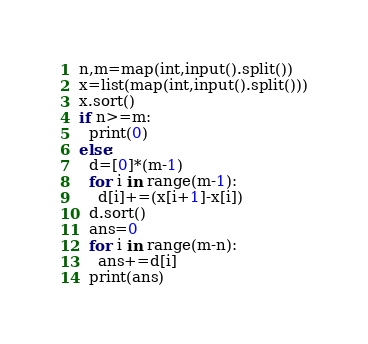Convert code to text. <code><loc_0><loc_0><loc_500><loc_500><_Python_>n,m=map(int,input().split())
x=list(map(int,input().split()))
x.sort()
if n>=m:
  print(0)
else:
  d=[0]*(m-1)
  for i in range(m-1):
    d[i]+=(x[i+1]-x[i])
  d.sort()
  ans=0
  for i in range(m-n):
    ans+=d[i]
  print(ans)</code> 